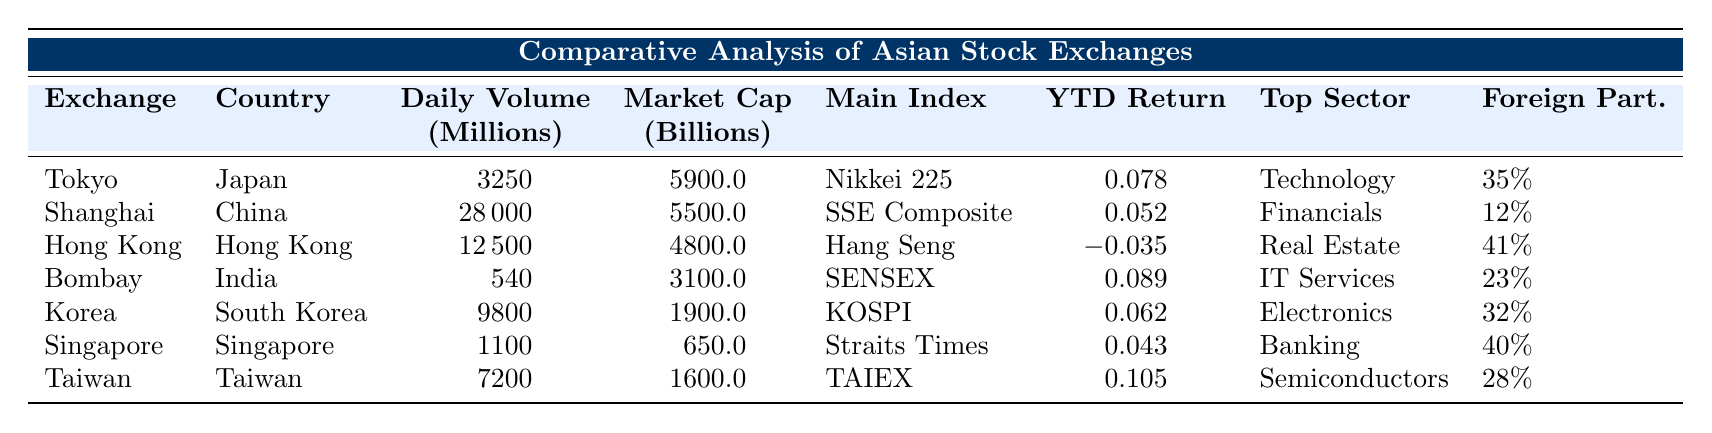What is the daily trading volume of the Tokyo Stock Exchange? The table lists the daily trading volume for the Tokyo Stock Exchange as 3,250 million.
Answer: 3,250 million Which stock exchange has the highest market capitalization? Comparing the market capitalizations listed in the table, the Tokyo Stock Exchange has the highest at 5,900 billion.
Answer: Tokyo Stock Exchange What is the YTD return of the Hong Kong Stock Exchange? The YTD return for the Hong Kong Stock Exchange is shown in the table as -0.035.
Answer: -0.035 What is the foreign investor participation percentage in the Shanghai Stock Exchange? According to the table, the foreign investor participation in the Shanghai Stock Exchange is 12%.
Answer: 12% Which exchange has the top sector listed as Technology? The table indicates that the Tokyo Stock Exchange has Technology as its top sector.
Answer: Tokyo Stock Exchange Calculate the average foreign investor participation across all stock exchanges. The foreign investor participation values from the table are 35%, 12%, 41%, 23%, 32%, 40%, and 28%. Summing these gives 35 + 12 + 41 + 23 + 32 + 40 + 28 = 211. Dividing by 7 exchanges results in an average of 30.14%.
Answer: 30.14% Is the daily trading volume of the Singapore Exchange greater than the Bombay Stock Exchange? The table shows Singapore Exchange's volume as 1,100 million and Bombay's as 540 million, confirming that Singapore's daily trading volume is greater.
Answer: Yes Which stock exchange has the lowest YTD return? The YTD returns listed in the table show that the Hong Kong Stock Exchange has the lowest return at -0.035.
Answer: Hong Kong Stock Exchange What is the difference in daily trading volume between the Tokyo Stock Exchange and the Shanghai Stock Exchange? The Tokyo Stock Exchange has a daily trading volume of 3,250 million, while the Shanghai Stock Exchange has 28,000 million. The difference is 28,000 - 3,250 = 24,750 million.
Answer: 24,750 million Which stock exchange has the highest YTD return and what is its value? Upon reviewing the YTD return values, the Taiwan Stock Exchange has the highest return at 0.105.
Answer: Taiwan Stock Exchange, 0.105 